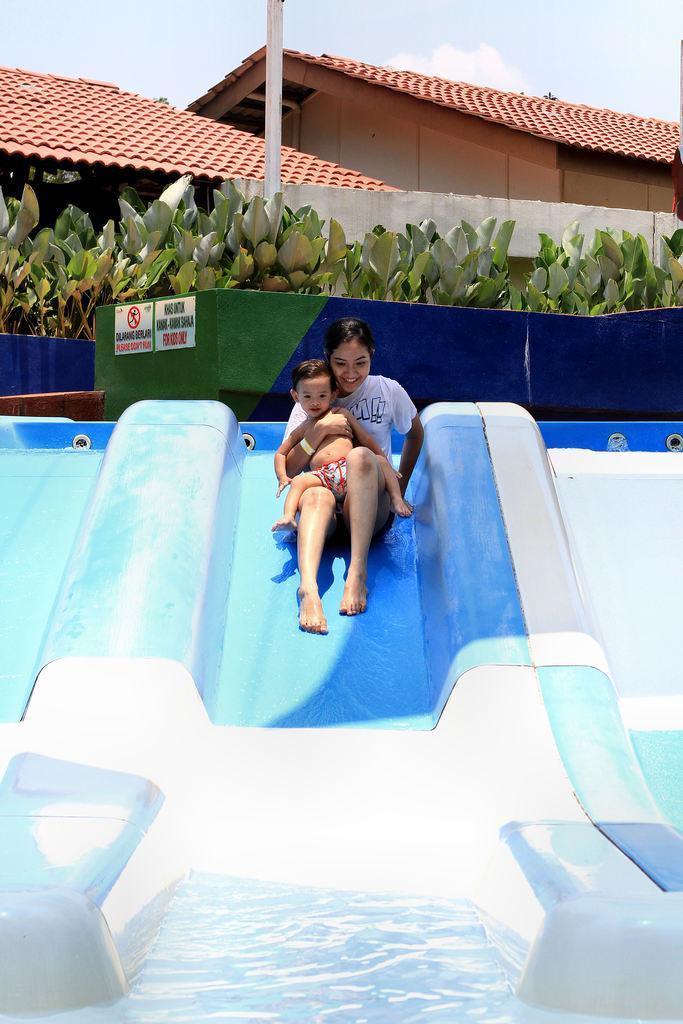How would you summarize this image in a sentence or two? In the front of the image there is water, mini water slides, a woman and a boy. Woman is holding a boy and sliding the mini water slide. In the background of the image there are shelters, a pole, posters, plants and the sky. Something is written on the posters.   